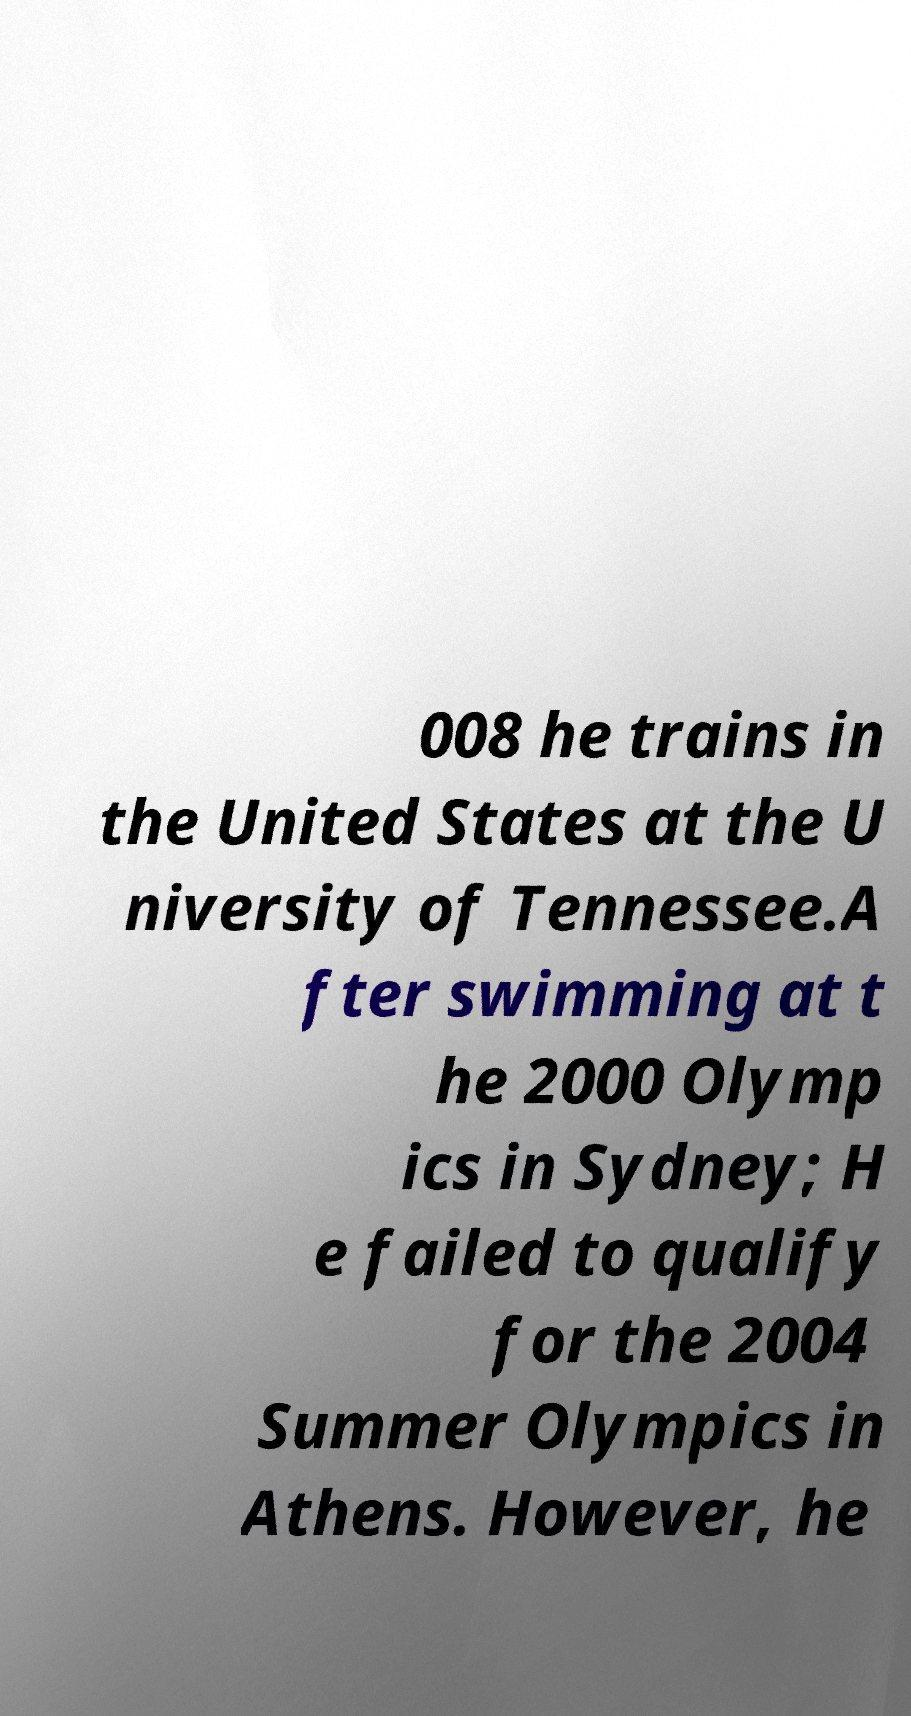For documentation purposes, I need the text within this image transcribed. Could you provide that? 008 he trains in the United States at the U niversity of Tennessee.A fter swimming at t he 2000 Olymp ics in Sydney; H e failed to qualify for the 2004 Summer Olympics in Athens. However, he 